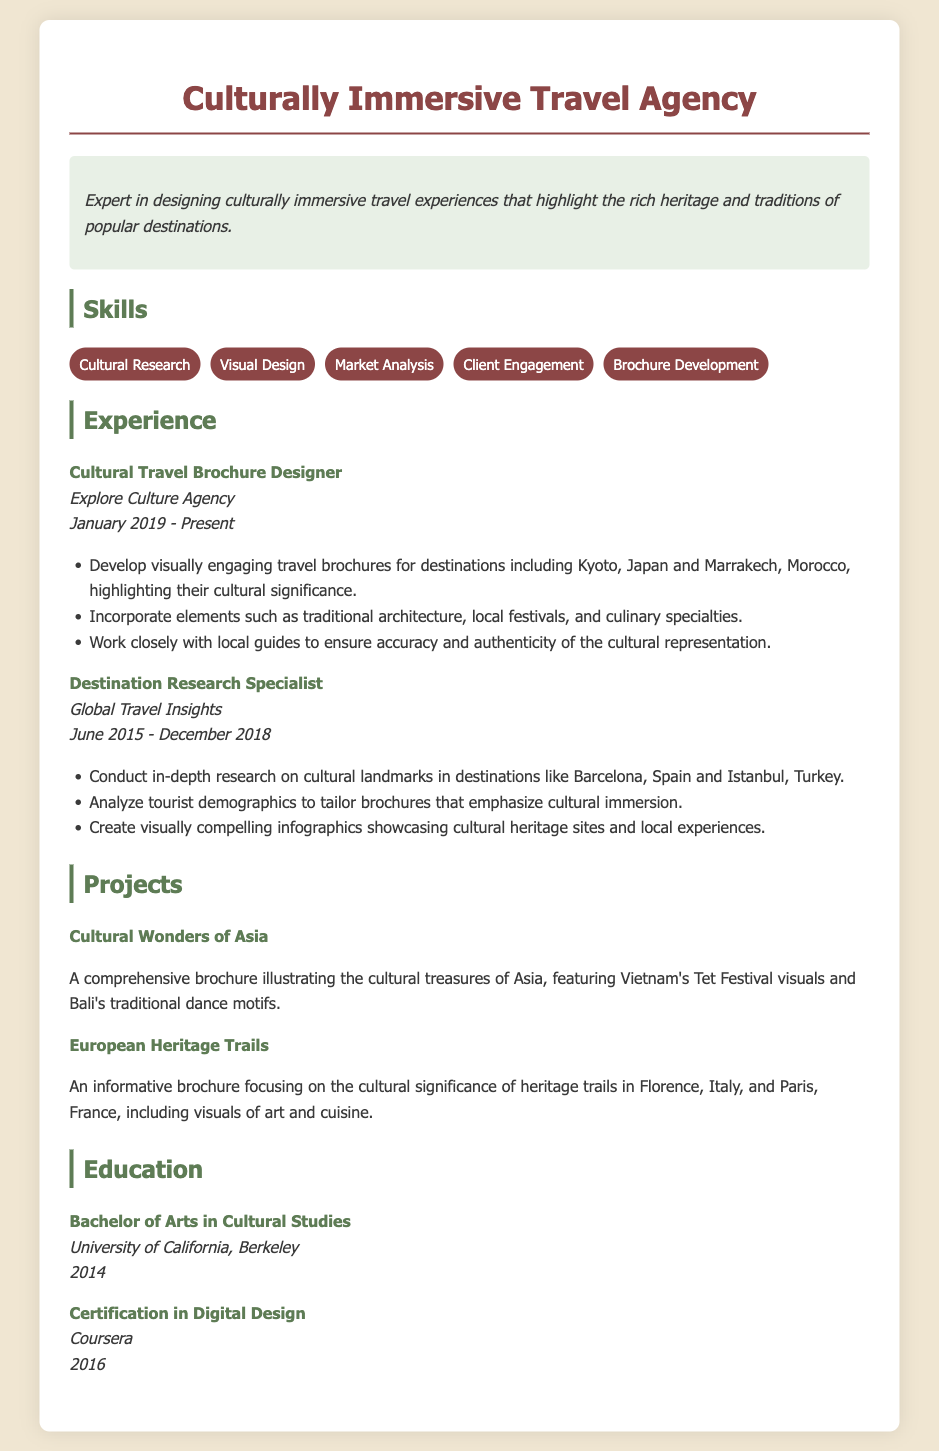What is the name of the travel agency? The agency is called "Culturally Immersive Travel Agency" as mentioned in the title of the document.
Answer: Culturally Immersive Travel Agency When did the Cultural Travel Brochure Designer position start? The position started in January 2019 as stated in the experience section of the resume.
Answer: January 2019 Which company did the person work for as a Destination Research Specialist? The company is "Global Travel Insights," mentioned in the experience section.
Answer: Global Travel Insights What type of degree does the person hold? The person has a Bachelor of Arts in Cultural Studies, which is detailed in the education section.
Answer: Bachelor of Arts in Cultural Studies What project highlights cultural treasures of Asia? The project named "Cultural Wonders of Asia" focuses on the cultural treasures of Asia according to the projects section.
Answer: Cultural Wonders of Asia How many skills are listed under the skills section? There are five skills listed under the skills section of the resume.
Answer: Five What specific design element is incorporated in the brochures developed by the person? The brochures incorporate elements such as traditional architecture, as listed in the experience section.
Answer: Traditional architecture Which festival is visually represented in the "Cultural Wonders of Asia" brochure? The festival is the "Tet Festival" of Vietnam mentioned in the project description.
Answer: Tet Festival What year did the person obtain their Bachelor of Arts degree? The degree was obtained in the year 2014, as stated in the education section.
Answer: 2014 